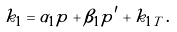<formula> <loc_0><loc_0><loc_500><loc_500>k _ { 1 } = \alpha _ { 1 } p + \beta _ { 1 } p ^ { \prime } + k _ { 1 T } \, .</formula> 